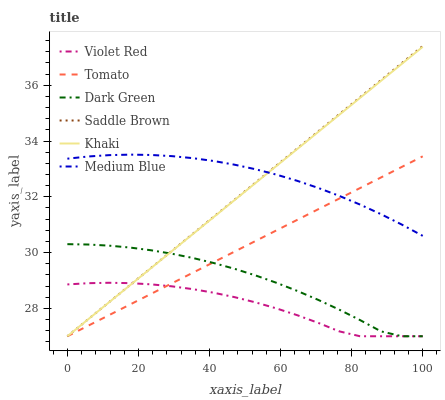Does Khaki have the minimum area under the curve?
Answer yes or no. No. Does Khaki have the maximum area under the curve?
Answer yes or no. No. Is Violet Red the smoothest?
Answer yes or no. No. Is Violet Red the roughest?
Answer yes or no. No. Does Medium Blue have the lowest value?
Answer yes or no. No. Does Khaki have the highest value?
Answer yes or no. No. Is Violet Red less than Medium Blue?
Answer yes or no. Yes. Is Medium Blue greater than Dark Green?
Answer yes or no. Yes. Does Violet Red intersect Medium Blue?
Answer yes or no. No. 